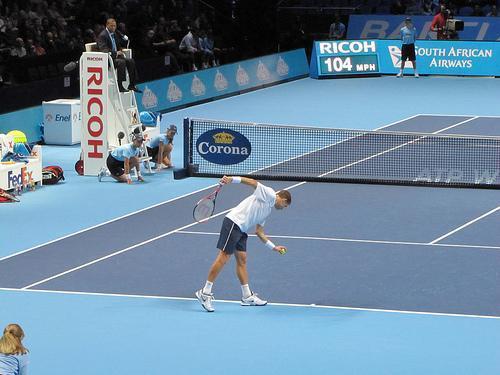How many people are in the court?
Give a very brief answer. 5. 